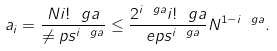Convert formula to latex. <formula><loc_0><loc_0><loc_500><loc_500>a _ { i } = \frac { N i ! ^ { \ } g a } { \ne p s ^ { i \ g a } } \leq \frac { 2 ^ { i \ g a } i ! ^ { \ } g a } { \ e p s ^ { i \ g a } } N ^ { 1 - i \ g a } .</formula> 